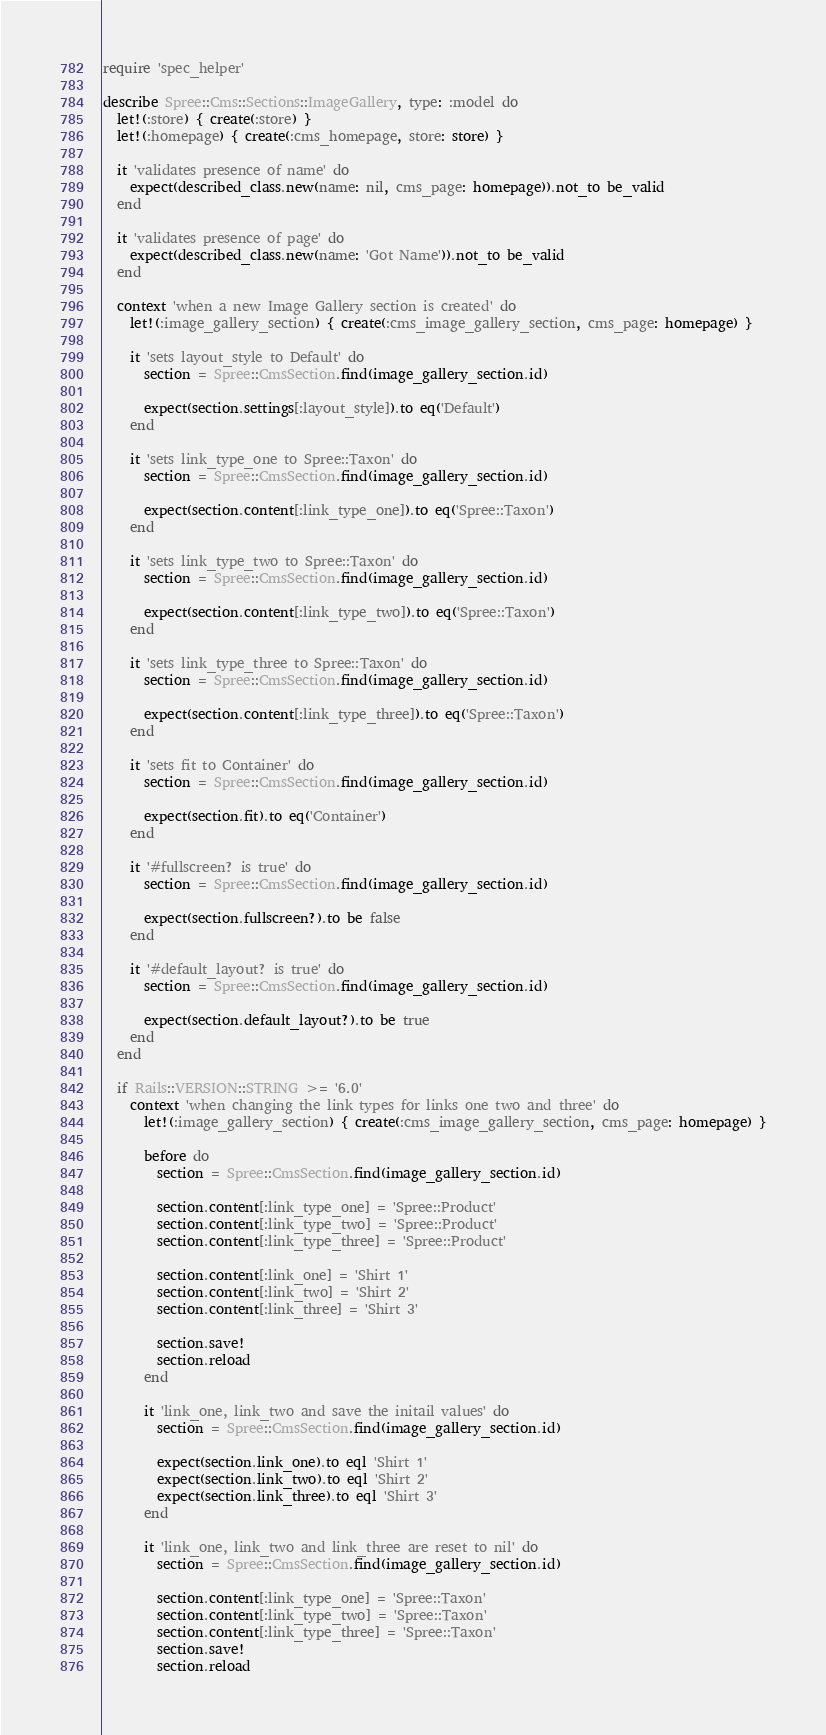<code> <loc_0><loc_0><loc_500><loc_500><_Ruby_>require 'spec_helper'

describe Spree::Cms::Sections::ImageGallery, type: :model do
  let!(:store) { create(:store) }
  let!(:homepage) { create(:cms_homepage, store: store) }

  it 'validates presence of name' do
    expect(described_class.new(name: nil, cms_page: homepage)).not_to be_valid
  end

  it 'validates presence of page' do
    expect(described_class.new(name: 'Got Name')).not_to be_valid
  end

  context 'when a new Image Gallery section is created' do
    let!(:image_gallery_section) { create(:cms_image_gallery_section, cms_page: homepage) }

    it 'sets layout_style to Default' do
      section = Spree::CmsSection.find(image_gallery_section.id)

      expect(section.settings[:layout_style]).to eq('Default')
    end

    it 'sets link_type_one to Spree::Taxon' do
      section = Spree::CmsSection.find(image_gallery_section.id)

      expect(section.content[:link_type_one]).to eq('Spree::Taxon')
    end

    it 'sets link_type_two to Spree::Taxon' do
      section = Spree::CmsSection.find(image_gallery_section.id)

      expect(section.content[:link_type_two]).to eq('Spree::Taxon')
    end

    it 'sets link_type_three to Spree::Taxon' do
      section = Spree::CmsSection.find(image_gallery_section.id)

      expect(section.content[:link_type_three]).to eq('Spree::Taxon')
    end

    it 'sets fit to Container' do
      section = Spree::CmsSection.find(image_gallery_section.id)

      expect(section.fit).to eq('Container')
    end

    it '#fullscreen? is true' do
      section = Spree::CmsSection.find(image_gallery_section.id)

      expect(section.fullscreen?).to be false
    end

    it '#default_layout? is true' do
      section = Spree::CmsSection.find(image_gallery_section.id)

      expect(section.default_layout?).to be true
    end
  end

  if Rails::VERSION::STRING >= '6.0'
    context 'when changing the link types for links one two and three' do
      let!(:image_gallery_section) { create(:cms_image_gallery_section, cms_page: homepage) }

      before do
        section = Spree::CmsSection.find(image_gallery_section.id)

        section.content[:link_type_one] = 'Spree::Product'
        section.content[:link_type_two] = 'Spree::Product'
        section.content[:link_type_three] = 'Spree::Product'

        section.content[:link_one] = 'Shirt 1'
        section.content[:link_two] = 'Shirt 2'
        section.content[:link_three] = 'Shirt 3'

        section.save!
        section.reload
      end

      it 'link_one, link_two and save the initail values' do
        section = Spree::CmsSection.find(image_gallery_section.id)

        expect(section.link_one).to eql 'Shirt 1'
        expect(section.link_two).to eql 'Shirt 2'
        expect(section.link_three).to eql 'Shirt 3'
      end

      it 'link_one, link_two and link_three are reset to nil' do
        section = Spree::CmsSection.find(image_gallery_section.id)

        section.content[:link_type_one] = 'Spree::Taxon'
        section.content[:link_type_two] = 'Spree::Taxon'
        section.content[:link_type_three] = 'Spree::Taxon'
        section.save!
        section.reload
</code> 